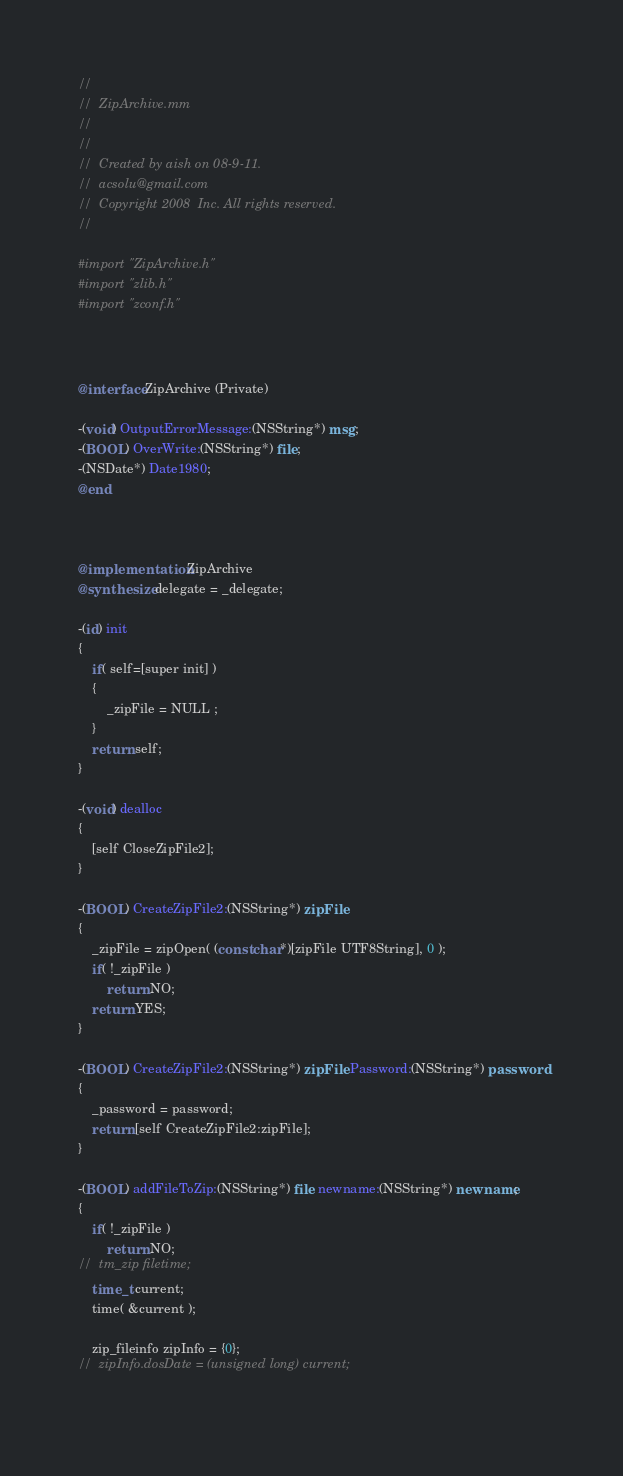<code> <loc_0><loc_0><loc_500><loc_500><_ObjectiveC_>//
//  ZipArchive.mm
//  
//
//  Created by aish on 08-9-11.
//  acsolu@gmail.com
//  Copyright 2008  Inc. All rights reserved.
//

#import "ZipArchive.h"
#import "zlib.h"
#import "zconf.h"



@interface ZipArchive (Private)

-(void) OutputErrorMessage:(NSString*) msg;
-(BOOL) OverWrite:(NSString*) file;
-(NSDate*) Date1980;
@end



@implementation ZipArchive
@synthesize delegate = _delegate;

-(id) init
{
	if( self=[super init] )
	{
		_zipFile = NULL ;
	}
	return self;
}

-(void) dealloc
{
	[self CloseZipFile2];
}

-(BOOL) CreateZipFile2:(NSString*) zipFile
{
	_zipFile = zipOpen( (const char*)[zipFile UTF8String], 0 );
	if( !_zipFile ) 
		return NO;
	return YES;
}

-(BOOL) CreateZipFile2:(NSString*) zipFile Password:(NSString*) password
{
	_password = password;
	return [self CreateZipFile2:zipFile];
}

-(BOOL) addFileToZip:(NSString*) file newname:(NSString*) newname;
{
	if( !_zipFile )
		return NO;
//	tm_zip filetime;
	time_t current;
	time( &current );
	
	zip_fileinfo zipInfo = {0};
//	zipInfo.dosDate = (unsigned long) current;
	</code> 